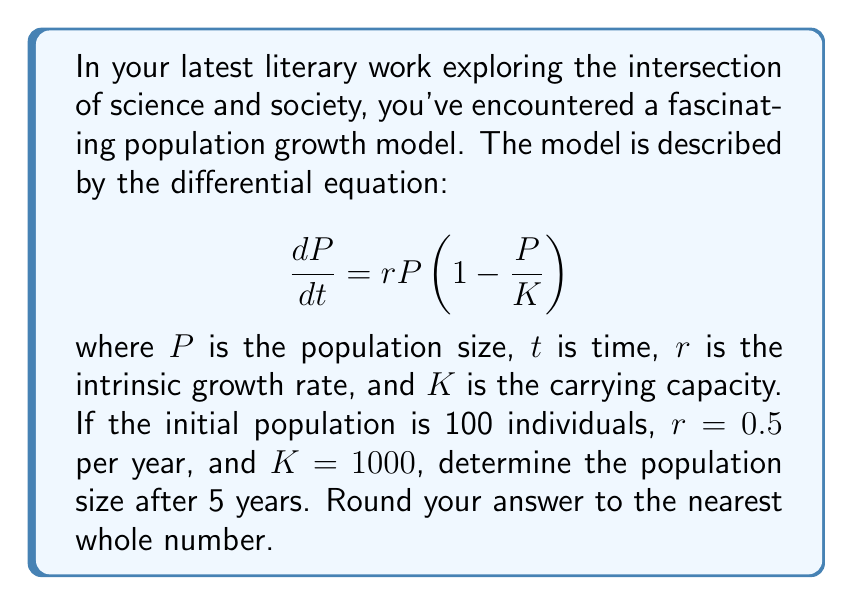What is the answer to this math problem? To solve this problem, we need to use the logistic growth model, which is described by the given differential equation. This equation doesn't have a straightforward analytical solution, so we'll use a numerical method called Euler's method to approximate the population size after 5 years.

1) First, let's define our variables:
   $P_0 = 100$ (initial population)
   $r = 0.5$ per year
   $K = 1000$
   $t = 5$ years

2) We'll use a small time step, let's say $\Delta t = 0.1$ years. This means we'll calculate the population 50 times (5 years / 0.1 years per step).

3) Euler's method is given by the formula:
   $P_{n+1} = P_n + \Delta t \cdot \frac{dP}{dt}$

   Where $\frac{dP}{dt} = rP\left(1 - \frac{P}{K}\right)$

4) Let's implement this in a step-by-step calculation:

   $P_0 = 100$
   $P_1 = P_0 + 0.1 \cdot 0.5 \cdot 100 \cdot (1 - 100/1000) = 104.5$
   $P_2 = P_1 + 0.1 \cdot 0.5 \cdot 104.5 \cdot (1 - 104.5/1000) = 109.2$
   ...

5) Continuing this process for 50 steps (5 years), we get:
   $P_{50} \approx 401.7$

6) Rounding to the nearest whole number, we get 402.
Answer: 402 individuals 